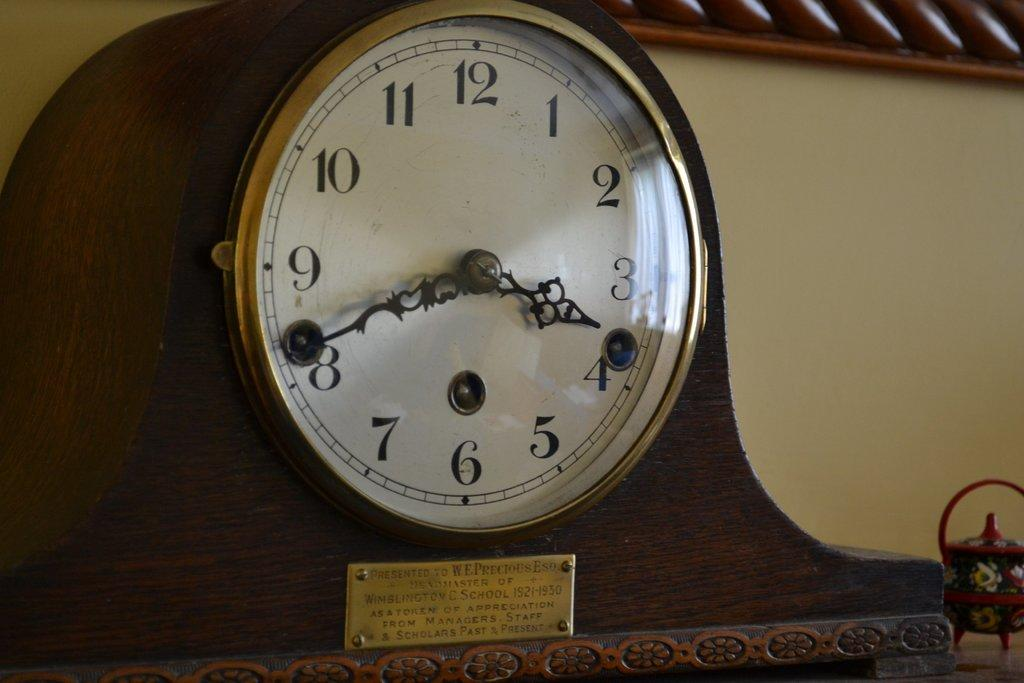<image>
Give a short and clear explanation of the subsequent image. Antique clock with the hands on the numbers 4 and 8. 